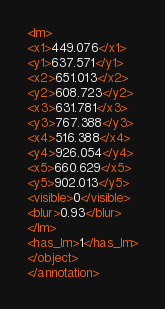<code> <loc_0><loc_0><loc_500><loc_500><_XML_><lm>
<x1>449.076</x1>
<y1>637.571</y1>
<x2>651.013</x2>
<y2>608.723</y2>
<x3>631.781</x3>
<y3>767.388</y3>
<x4>516.388</x4>
<y4>926.054</y4>
<x5>660.629</x5>
<y5>902.013</y5>
<visible>0</visible>
<blur>0.93</blur>
</lm>
<has_lm>1</has_lm>
</object>
</annotation></code> 